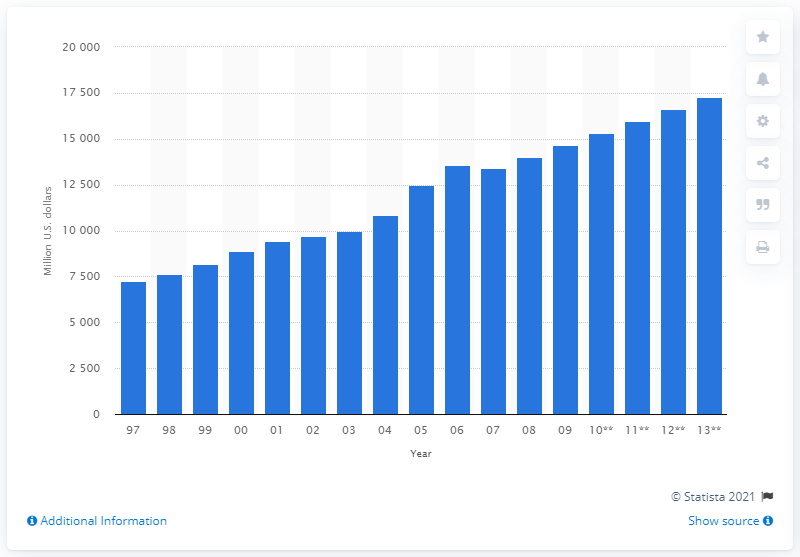Give some essential details in this illustration. In 2006, California spent a significant amount of money on road infrastructure. Specifically, the state spent 13,561 on road infrastructure that year. In 2012, California spent approximately 16,639 dollars on road infrastructure. 